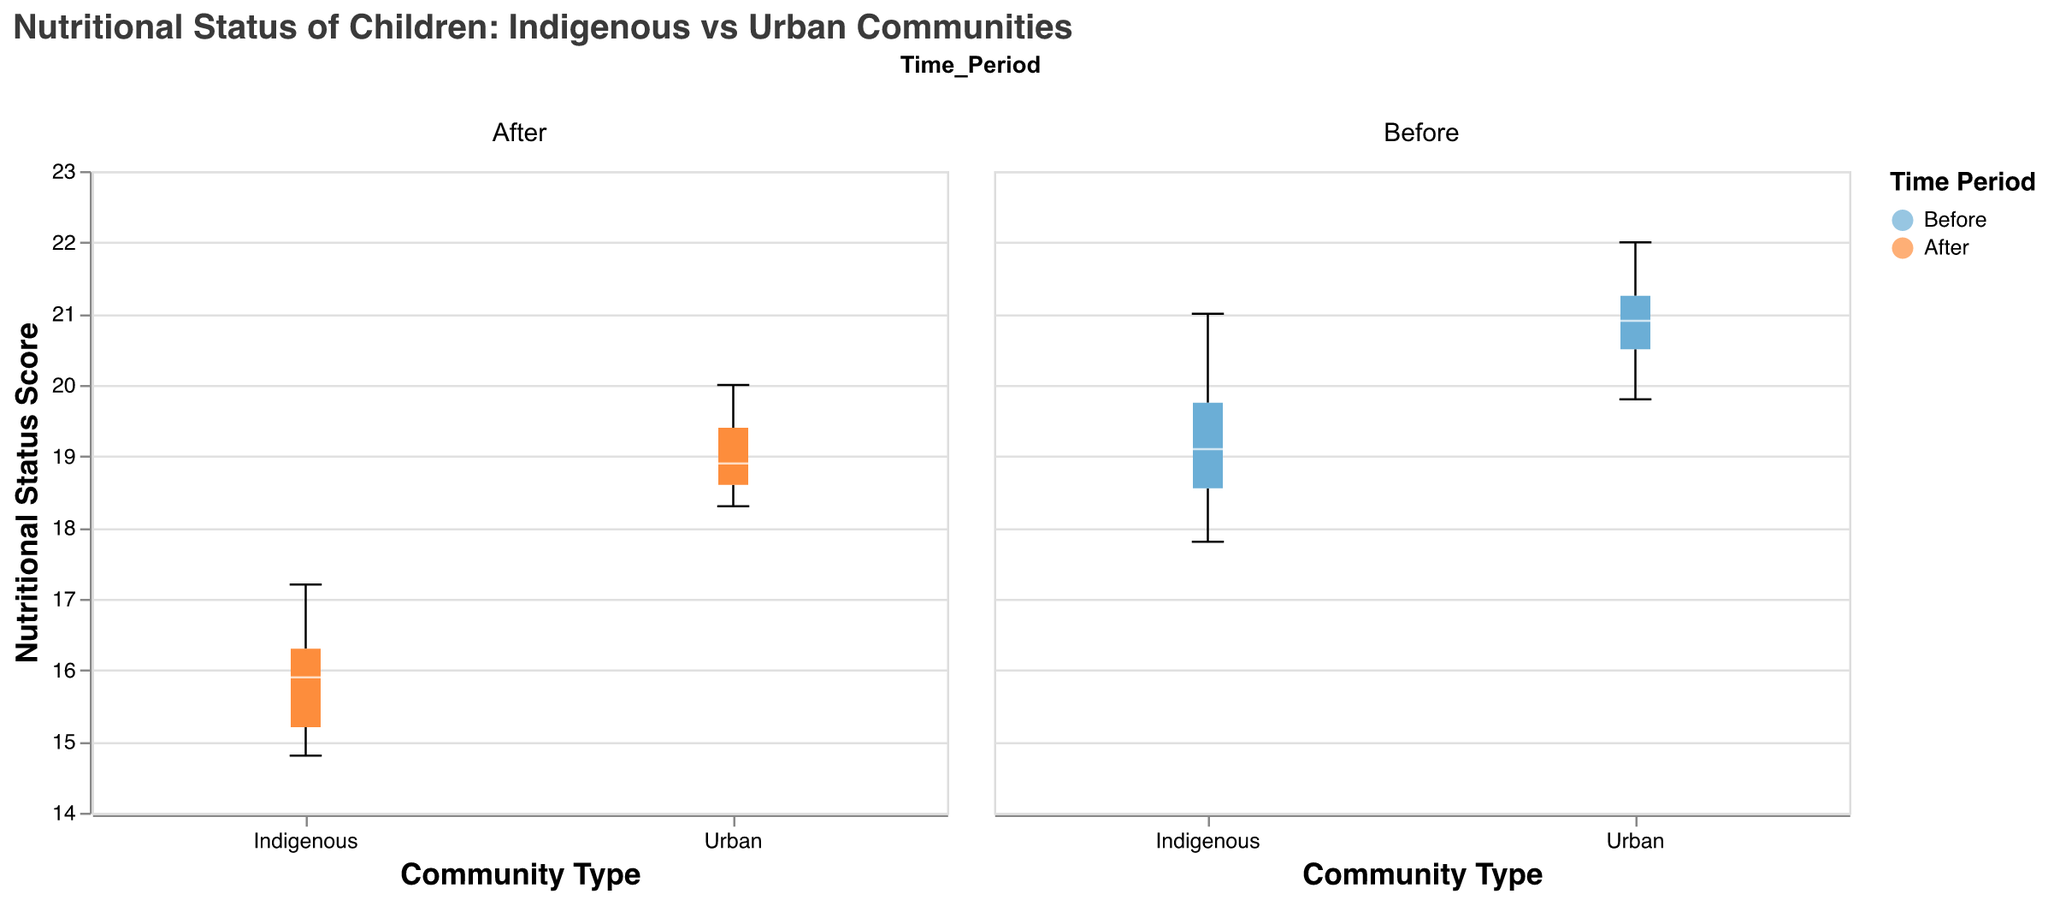What is the title of the figure? The title of the figure is displayed at the top of the chart. It reads "Nutritional Status of Children: Indigenous vs Urban Communities."
Answer: Nutritional Status of Children: Indigenous vs Urban Communities What are the two groups compared in the figure? The two groups compared in the figure are displayed on the x-axis, labeled as "Community Type". The groups are "Indigenous" and "Urban".
Answer: Indigenous and Urban How many time periods are represented in the figure, and what are they? The figure shows two distinct time periods, indicated by the different colors in the legend. These time periods are "Before" and "After".
Answer: Before and After What are the color codes used to represent the two time periods? The legend shows that the time periods are represented by two colors: "Before" is blue, and "After" is orange.
Answer: Blue and Orange What is the general trend in the nutritional status of children in indigenous communities before and after industrial development? By observing the position and spread of the box plots for the indigenous community, we notice that the nutritional status generally declines after industrial development. The box representing the "After" period is positioned lower than the "Before" period.
Answer: It declines How does the nutritional status of children in urban areas change after industrial development? The box plot for urban areas shows a decrease in nutritional status after industrial development. The median line of the "After" box plot is lower compared to the "Before" box plot.
Answer: It decreases Compare the median nutritional status of children in indigenous communities before industrial development to their urban counterparts before industrial development. By comparing the median lines in the box plots, we can see that the median nutritional status for urban children is slightly higher than for indigenous children before industrial development.
Answer: Urban is higher Which group and time period have the highest nutritional status? By examining the top whisker and maximum data points, we can see that the "Urban" group during the "Before" time period has the highest nutritional status.
Answer: Urban Before What is the range of nutritional status scores for indigenous children before and after industrial development? The range is the difference between the maximum and minimum values. For indigenous children, "Before" ranges from 17.8 to 21.0, and "After" ranges from 14.8 to 17.2.
Answer: Before: 3.2; After: 2.4 Based on the visual information in the figure, which time period seems to have more consistent nutritional status among children in both communities? Consistency can be observed from the spread and interquartile range of the box plots. The nutritional status appears more consistent for the "After" period, as the spread and interquartile ranges are smaller for both indigenous and urban children.
Answer: After 